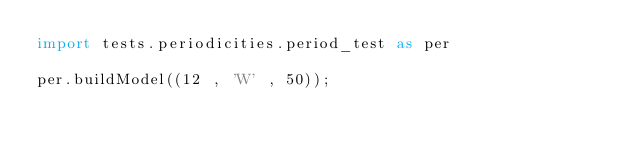<code> <loc_0><loc_0><loc_500><loc_500><_Python_>import tests.periodicities.period_test as per

per.buildModel((12 , 'W' , 50));

</code> 